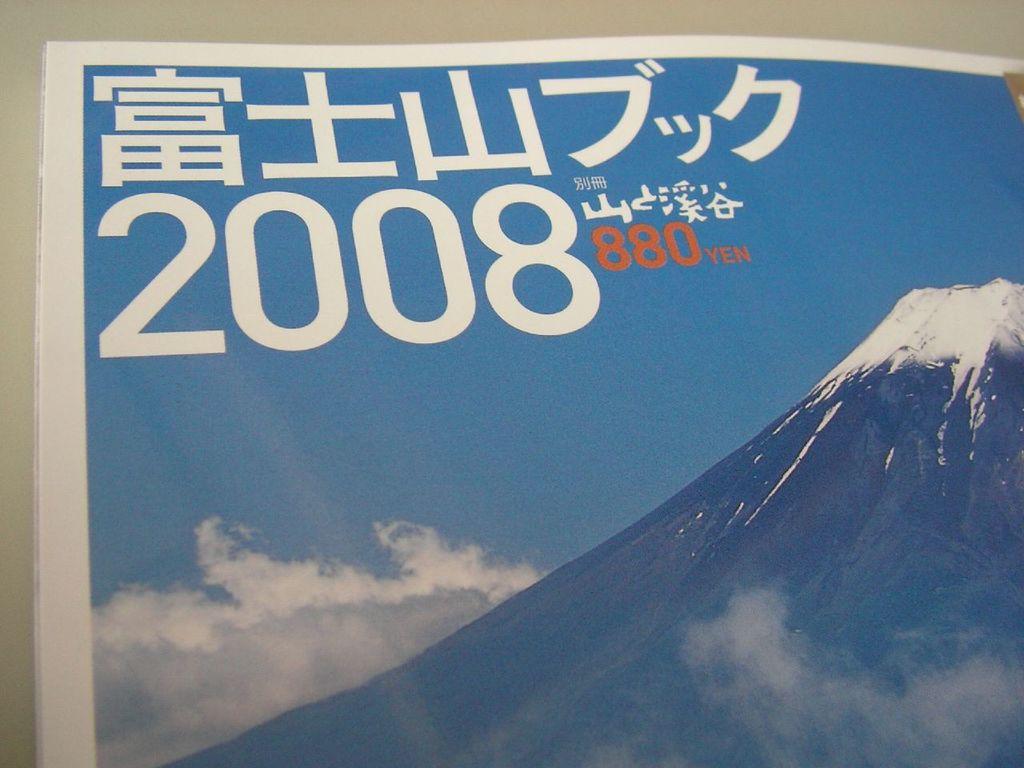What is the year?
Offer a very short reply. 2008. How many yen?
Your response must be concise. 880. 